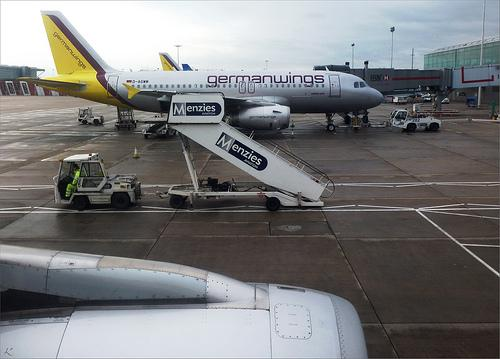Question: what is on the runway?
Choices:
A. A jet.
B. A pilot.
C. A plane.
D. A safety crew.
Answer with the letter. Answer: C Question: where was the picture taken?
Choices:
A. At an airport.
B. A train station.
C. A bus terminal.
D. A shipping port.
Answer with the letter. Answer: A Question: what is yellow?
Choices:
A. Plane's tail.
B. Plane's wing.
C. Plane's door.
D. Lettering on the side of the plane.
Answer with the letter. Answer: A Question: where are white lines?
Choices:
A. On the street.
B. On the parking lot.
C. On the ground.
D. On the crosswalk.
Answer with the letter. Answer: C Question: what has many windows?
Choices:
A. The plane.
B. The bus.
C. The house.
D. The skyscraper.
Answer with the letter. Answer: A 